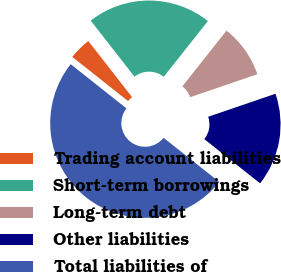<chart> <loc_0><loc_0><loc_500><loc_500><pie_chart><fcel>Trading account liabilities<fcel>Short-term borrowings<fcel>Long-term debt<fcel>Other liabilities<fcel>Total liabilities of<nl><fcel>3.79%<fcel>21.21%<fcel>9.09%<fcel>15.91%<fcel>50.0%<nl></chart> 